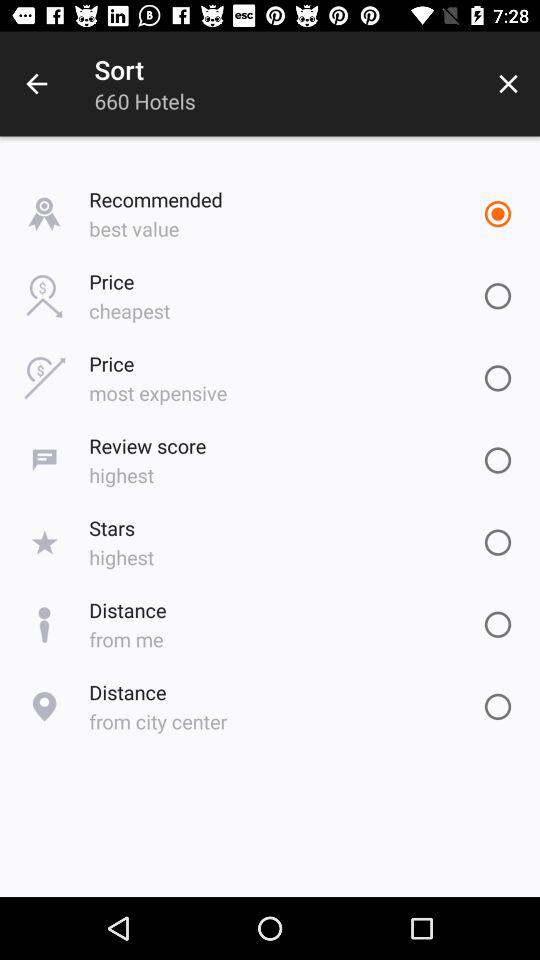How many hotels are there? There are 660 hotels. 